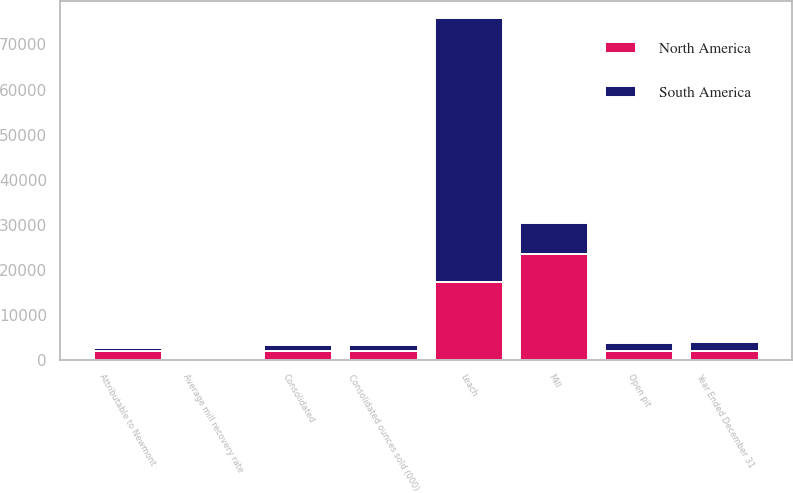Convert chart to OTSL. <chart><loc_0><loc_0><loc_500><loc_500><stacked_bar_chart><ecel><fcel>Year Ended December 31<fcel>Open pit<fcel>Mill<fcel>Leach<fcel>Average mill recovery rate<fcel>Consolidated<fcel>Attributable to Newmont<fcel>Consolidated ounces sold (000)<nl><fcel>North America<fcel>2010<fcel>1909<fcel>23497<fcel>17240<fcel>78.9<fcel>1909<fcel>1909<fcel>1898<nl><fcel>South America<fcel>2010<fcel>1909<fcel>6832<fcel>58691<fcel>82.5<fcel>1462<fcel>771<fcel>1463<nl></chart> 